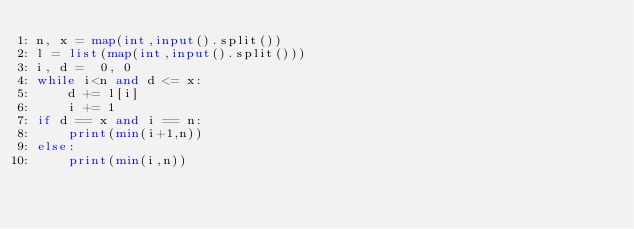<code> <loc_0><loc_0><loc_500><loc_500><_Python_>n, x = map(int,input().split())
l = list(map(int,input().split()))
i, d =  0, 0
while i<n and d <= x:
    d += l[i]
    i += 1
if d == x and i == n:
    print(min(i+1,n))
else:
    print(min(i,n))</code> 